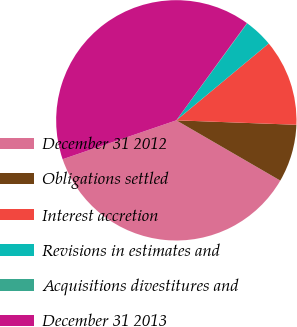Convert chart to OTSL. <chart><loc_0><loc_0><loc_500><loc_500><pie_chart><fcel>December 31 2012<fcel>Obligations settled<fcel>Interest accretion<fcel>Revisions in estimates and<fcel>Acquisitions divestitures and<fcel>December 31 2013<nl><fcel>36.39%<fcel>7.77%<fcel>11.63%<fcel>3.91%<fcel>0.05%<fcel>40.24%<nl></chart> 